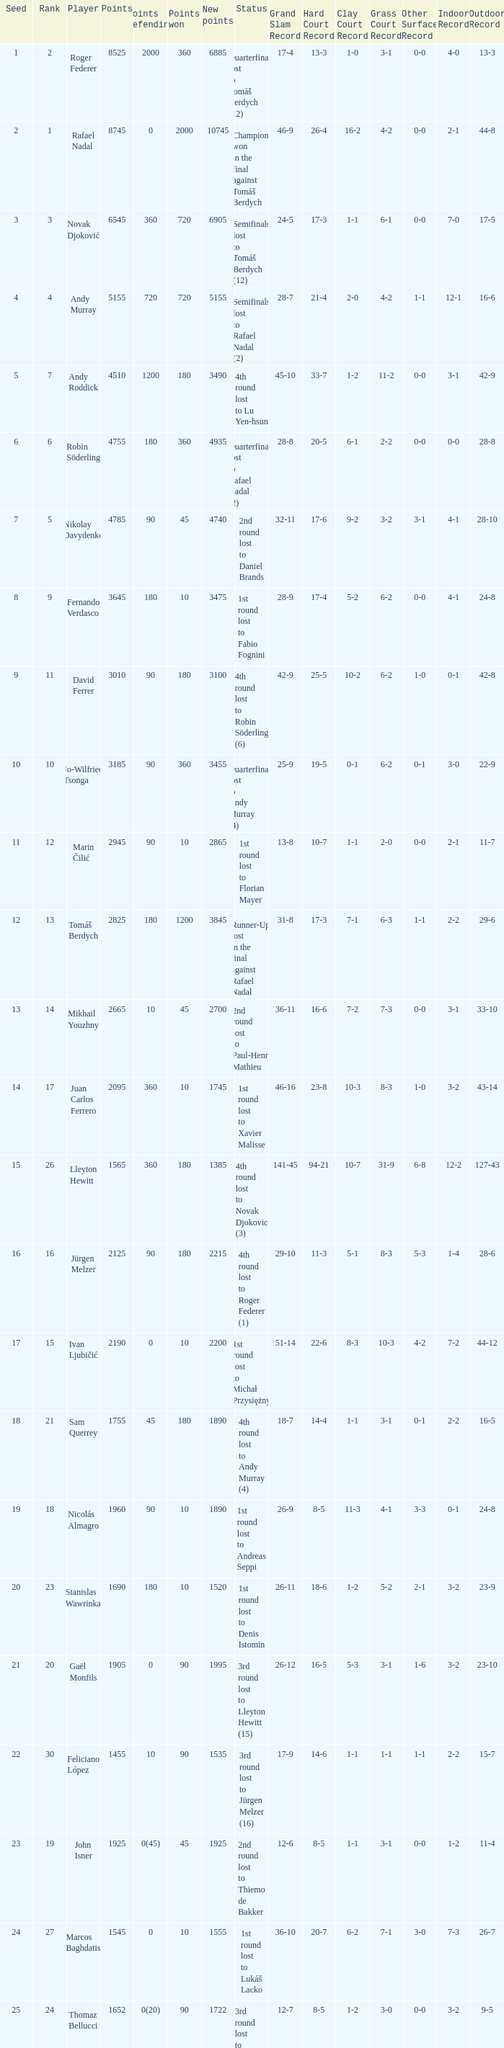Name the number of points defending for 1075 1.0. 